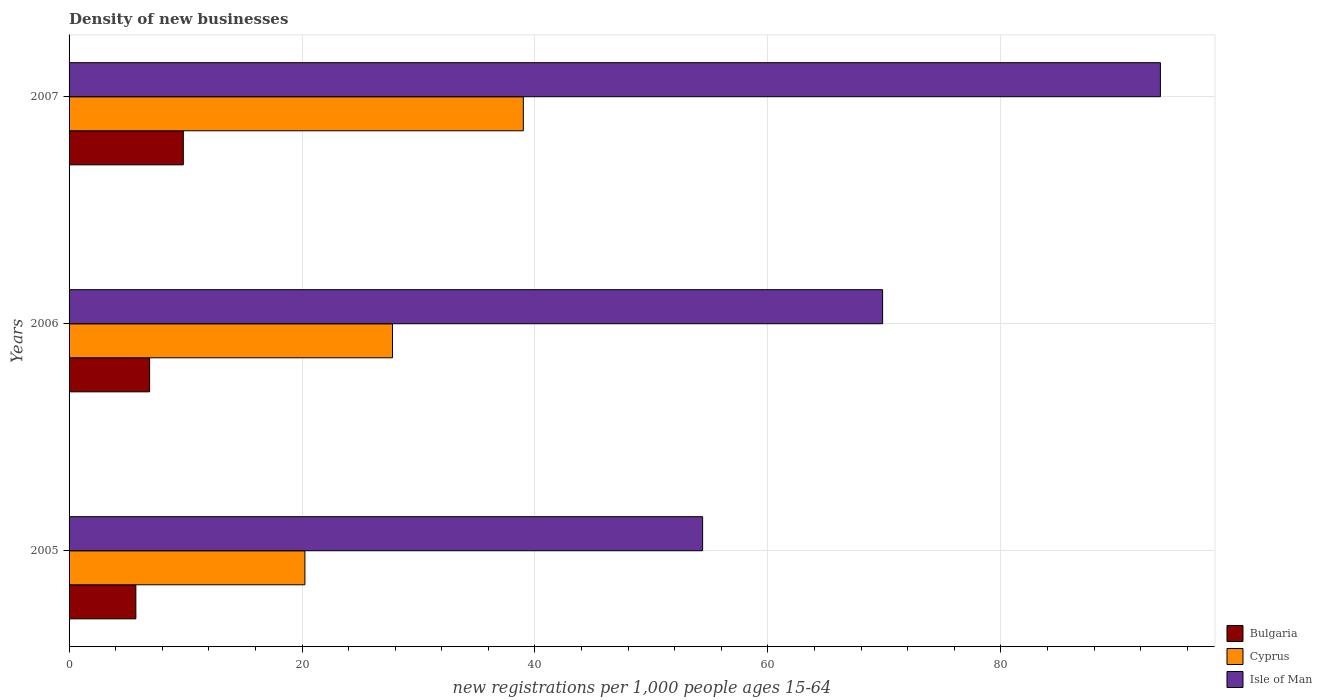How many different coloured bars are there?
Your answer should be very brief. 3. How many groups of bars are there?
Offer a very short reply. 3. What is the label of the 2nd group of bars from the top?
Ensure brevity in your answer.  2006. What is the number of new registrations in Isle of Man in 2006?
Provide a short and direct response. 69.85. Across all years, what is the maximum number of new registrations in Cyprus?
Ensure brevity in your answer.  39. Across all years, what is the minimum number of new registrations in Cyprus?
Your answer should be very brief. 20.25. In which year was the number of new registrations in Bulgaria maximum?
Keep it short and to the point. 2007. In which year was the number of new registrations in Isle of Man minimum?
Keep it short and to the point. 2005. What is the total number of new registrations in Isle of Man in the graph?
Ensure brevity in your answer.  217.95. What is the difference between the number of new registrations in Bulgaria in 2005 and that in 2006?
Ensure brevity in your answer.  -1.18. What is the difference between the number of new registrations in Bulgaria in 2006 and the number of new registrations in Cyprus in 2005?
Give a very brief answer. -13.33. What is the average number of new registrations in Isle of Man per year?
Provide a succinct answer. 72.65. In the year 2006, what is the difference between the number of new registrations in Cyprus and number of new registrations in Isle of Man?
Provide a short and direct response. -42.08. In how many years, is the number of new registrations in Bulgaria greater than 20 ?
Your answer should be compact. 0. What is the ratio of the number of new registrations in Isle of Man in 2005 to that in 2006?
Ensure brevity in your answer.  0.78. Is the difference between the number of new registrations in Cyprus in 2006 and 2007 greater than the difference between the number of new registrations in Isle of Man in 2006 and 2007?
Make the answer very short. Yes. What is the difference between the highest and the second highest number of new registrations in Bulgaria?
Offer a very short reply. 2.89. What is the difference between the highest and the lowest number of new registrations in Bulgaria?
Provide a succinct answer. 4.07. In how many years, is the number of new registrations in Bulgaria greater than the average number of new registrations in Bulgaria taken over all years?
Provide a short and direct response. 1. Is the sum of the number of new registrations in Bulgaria in 2005 and 2006 greater than the maximum number of new registrations in Cyprus across all years?
Offer a very short reply. No. What does the 1st bar from the top in 2006 represents?
Your answer should be compact. Isle of Man. What does the 1st bar from the bottom in 2006 represents?
Your answer should be very brief. Bulgaria. Is it the case that in every year, the sum of the number of new registrations in Isle of Man and number of new registrations in Bulgaria is greater than the number of new registrations in Cyprus?
Ensure brevity in your answer.  Yes. Are all the bars in the graph horizontal?
Keep it short and to the point. Yes. How many years are there in the graph?
Your answer should be very brief. 3. Are the values on the major ticks of X-axis written in scientific E-notation?
Make the answer very short. No. How are the legend labels stacked?
Offer a terse response. Vertical. What is the title of the graph?
Provide a succinct answer. Density of new businesses. What is the label or title of the X-axis?
Make the answer very short. New registrations per 1,0 people ages 15-64. What is the label or title of the Y-axis?
Keep it short and to the point. Years. What is the new registrations per 1,000 people ages 15-64 of Bulgaria in 2005?
Your answer should be very brief. 5.73. What is the new registrations per 1,000 people ages 15-64 of Cyprus in 2005?
Give a very brief answer. 20.25. What is the new registrations per 1,000 people ages 15-64 of Isle of Man in 2005?
Give a very brief answer. 54.4. What is the new registrations per 1,000 people ages 15-64 in Bulgaria in 2006?
Your response must be concise. 6.91. What is the new registrations per 1,000 people ages 15-64 in Cyprus in 2006?
Your response must be concise. 27.77. What is the new registrations per 1,000 people ages 15-64 of Isle of Man in 2006?
Keep it short and to the point. 69.85. What is the new registrations per 1,000 people ages 15-64 of Bulgaria in 2007?
Ensure brevity in your answer.  9.81. What is the new registrations per 1,000 people ages 15-64 of Cyprus in 2007?
Ensure brevity in your answer.  39. What is the new registrations per 1,000 people ages 15-64 of Isle of Man in 2007?
Provide a succinct answer. 93.7. Across all years, what is the maximum new registrations per 1,000 people ages 15-64 in Bulgaria?
Offer a very short reply. 9.81. Across all years, what is the maximum new registrations per 1,000 people ages 15-64 in Cyprus?
Give a very brief answer. 39. Across all years, what is the maximum new registrations per 1,000 people ages 15-64 in Isle of Man?
Offer a very short reply. 93.7. Across all years, what is the minimum new registrations per 1,000 people ages 15-64 of Bulgaria?
Offer a very short reply. 5.73. Across all years, what is the minimum new registrations per 1,000 people ages 15-64 in Cyprus?
Offer a terse response. 20.25. Across all years, what is the minimum new registrations per 1,000 people ages 15-64 in Isle of Man?
Your answer should be very brief. 54.4. What is the total new registrations per 1,000 people ages 15-64 in Bulgaria in the graph?
Your answer should be compact. 22.46. What is the total new registrations per 1,000 people ages 15-64 of Cyprus in the graph?
Ensure brevity in your answer.  87.02. What is the total new registrations per 1,000 people ages 15-64 in Isle of Man in the graph?
Give a very brief answer. 217.95. What is the difference between the new registrations per 1,000 people ages 15-64 of Bulgaria in 2005 and that in 2006?
Ensure brevity in your answer.  -1.18. What is the difference between the new registrations per 1,000 people ages 15-64 in Cyprus in 2005 and that in 2006?
Keep it short and to the point. -7.52. What is the difference between the new registrations per 1,000 people ages 15-64 in Isle of Man in 2005 and that in 2006?
Provide a succinct answer. -15.45. What is the difference between the new registrations per 1,000 people ages 15-64 of Bulgaria in 2005 and that in 2007?
Give a very brief answer. -4.08. What is the difference between the new registrations per 1,000 people ages 15-64 of Cyprus in 2005 and that in 2007?
Offer a very short reply. -18.75. What is the difference between the new registrations per 1,000 people ages 15-64 of Isle of Man in 2005 and that in 2007?
Your answer should be very brief. -39.3. What is the difference between the new registrations per 1,000 people ages 15-64 in Bulgaria in 2006 and that in 2007?
Make the answer very short. -2.89. What is the difference between the new registrations per 1,000 people ages 15-64 in Cyprus in 2006 and that in 2007?
Ensure brevity in your answer.  -11.23. What is the difference between the new registrations per 1,000 people ages 15-64 in Isle of Man in 2006 and that in 2007?
Provide a short and direct response. -23.85. What is the difference between the new registrations per 1,000 people ages 15-64 of Bulgaria in 2005 and the new registrations per 1,000 people ages 15-64 of Cyprus in 2006?
Ensure brevity in your answer.  -22.03. What is the difference between the new registrations per 1,000 people ages 15-64 of Bulgaria in 2005 and the new registrations per 1,000 people ages 15-64 of Isle of Man in 2006?
Provide a succinct answer. -64.11. What is the difference between the new registrations per 1,000 people ages 15-64 of Cyprus in 2005 and the new registrations per 1,000 people ages 15-64 of Isle of Man in 2006?
Ensure brevity in your answer.  -49.6. What is the difference between the new registrations per 1,000 people ages 15-64 of Bulgaria in 2005 and the new registrations per 1,000 people ages 15-64 of Cyprus in 2007?
Make the answer very short. -33.27. What is the difference between the new registrations per 1,000 people ages 15-64 in Bulgaria in 2005 and the new registrations per 1,000 people ages 15-64 in Isle of Man in 2007?
Ensure brevity in your answer.  -87.97. What is the difference between the new registrations per 1,000 people ages 15-64 in Cyprus in 2005 and the new registrations per 1,000 people ages 15-64 in Isle of Man in 2007?
Offer a terse response. -73.45. What is the difference between the new registrations per 1,000 people ages 15-64 in Bulgaria in 2006 and the new registrations per 1,000 people ages 15-64 in Cyprus in 2007?
Make the answer very short. -32.09. What is the difference between the new registrations per 1,000 people ages 15-64 in Bulgaria in 2006 and the new registrations per 1,000 people ages 15-64 in Isle of Man in 2007?
Your answer should be compact. -86.79. What is the difference between the new registrations per 1,000 people ages 15-64 of Cyprus in 2006 and the new registrations per 1,000 people ages 15-64 of Isle of Man in 2007?
Offer a very short reply. -65.93. What is the average new registrations per 1,000 people ages 15-64 in Bulgaria per year?
Give a very brief answer. 7.49. What is the average new registrations per 1,000 people ages 15-64 of Cyprus per year?
Give a very brief answer. 29.01. What is the average new registrations per 1,000 people ages 15-64 in Isle of Man per year?
Offer a terse response. 72.65. In the year 2005, what is the difference between the new registrations per 1,000 people ages 15-64 of Bulgaria and new registrations per 1,000 people ages 15-64 of Cyprus?
Offer a very short reply. -14.51. In the year 2005, what is the difference between the new registrations per 1,000 people ages 15-64 of Bulgaria and new registrations per 1,000 people ages 15-64 of Isle of Man?
Provide a short and direct response. -48.66. In the year 2005, what is the difference between the new registrations per 1,000 people ages 15-64 in Cyprus and new registrations per 1,000 people ages 15-64 in Isle of Man?
Ensure brevity in your answer.  -34.15. In the year 2006, what is the difference between the new registrations per 1,000 people ages 15-64 of Bulgaria and new registrations per 1,000 people ages 15-64 of Cyprus?
Provide a short and direct response. -20.85. In the year 2006, what is the difference between the new registrations per 1,000 people ages 15-64 in Bulgaria and new registrations per 1,000 people ages 15-64 in Isle of Man?
Provide a succinct answer. -62.93. In the year 2006, what is the difference between the new registrations per 1,000 people ages 15-64 in Cyprus and new registrations per 1,000 people ages 15-64 in Isle of Man?
Your answer should be very brief. -42.08. In the year 2007, what is the difference between the new registrations per 1,000 people ages 15-64 of Bulgaria and new registrations per 1,000 people ages 15-64 of Cyprus?
Keep it short and to the point. -29.19. In the year 2007, what is the difference between the new registrations per 1,000 people ages 15-64 in Bulgaria and new registrations per 1,000 people ages 15-64 in Isle of Man?
Ensure brevity in your answer.  -83.89. In the year 2007, what is the difference between the new registrations per 1,000 people ages 15-64 in Cyprus and new registrations per 1,000 people ages 15-64 in Isle of Man?
Offer a terse response. -54.7. What is the ratio of the new registrations per 1,000 people ages 15-64 of Bulgaria in 2005 to that in 2006?
Your response must be concise. 0.83. What is the ratio of the new registrations per 1,000 people ages 15-64 of Cyprus in 2005 to that in 2006?
Offer a very short reply. 0.73. What is the ratio of the new registrations per 1,000 people ages 15-64 in Isle of Man in 2005 to that in 2006?
Your answer should be compact. 0.78. What is the ratio of the new registrations per 1,000 people ages 15-64 in Bulgaria in 2005 to that in 2007?
Your answer should be very brief. 0.58. What is the ratio of the new registrations per 1,000 people ages 15-64 in Cyprus in 2005 to that in 2007?
Your response must be concise. 0.52. What is the ratio of the new registrations per 1,000 people ages 15-64 in Isle of Man in 2005 to that in 2007?
Keep it short and to the point. 0.58. What is the ratio of the new registrations per 1,000 people ages 15-64 in Bulgaria in 2006 to that in 2007?
Your answer should be very brief. 0.7. What is the ratio of the new registrations per 1,000 people ages 15-64 in Cyprus in 2006 to that in 2007?
Your answer should be very brief. 0.71. What is the ratio of the new registrations per 1,000 people ages 15-64 in Isle of Man in 2006 to that in 2007?
Provide a succinct answer. 0.75. What is the difference between the highest and the second highest new registrations per 1,000 people ages 15-64 of Bulgaria?
Provide a short and direct response. 2.89. What is the difference between the highest and the second highest new registrations per 1,000 people ages 15-64 in Cyprus?
Make the answer very short. 11.23. What is the difference between the highest and the second highest new registrations per 1,000 people ages 15-64 in Isle of Man?
Ensure brevity in your answer.  23.85. What is the difference between the highest and the lowest new registrations per 1,000 people ages 15-64 in Bulgaria?
Provide a short and direct response. 4.08. What is the difference between the highest and the lowest new registrations per 1,000 people ages 15-64 of Cyprus?
Provide a short and direct response. 18.75. What is the difference between the highest and the lowest new registrations per 1,000 people ages 15-64 of Isle of Man?
Make the answer very short. 39.3. 